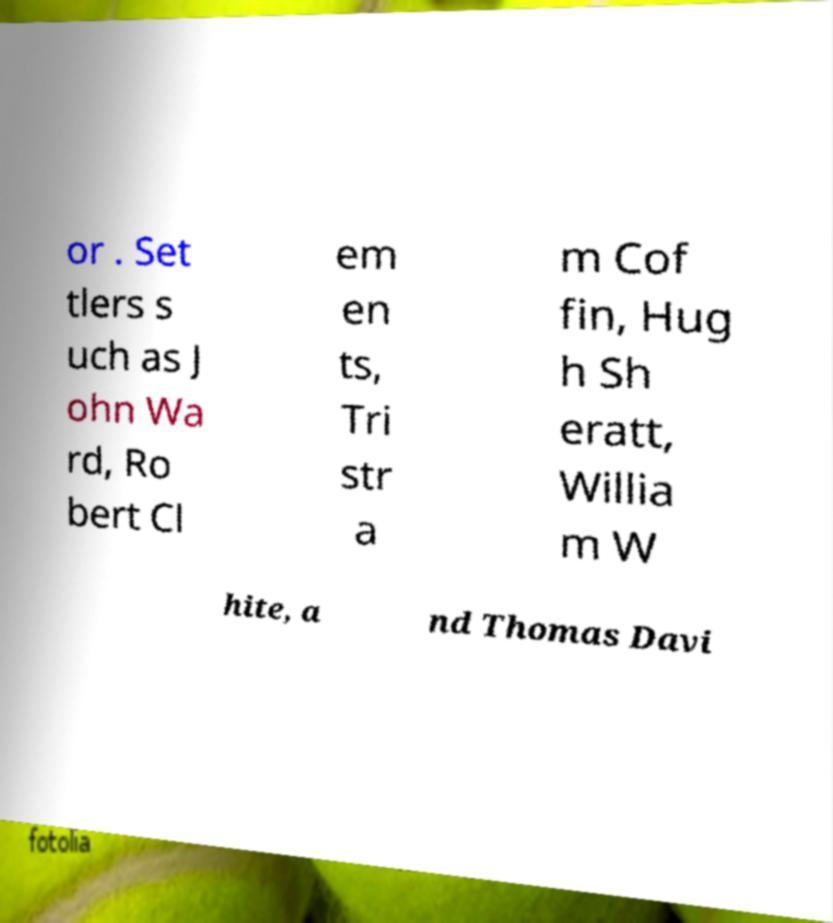Could you assist in decoding the text presented in this image and type it out clearly? or . Set tlers s uch as J ohn Wa rd, Ro bert Cl em en ts, Tri str a m Cof fin, Hug h Sh eratt, Willia m W hite, a nd Thomas Davi 